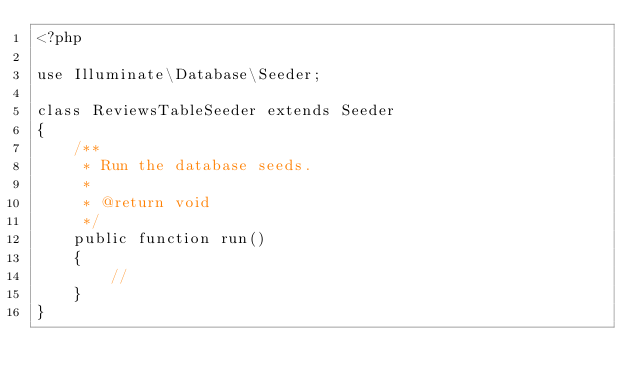Convert code to text. <code><loc_0><loc_0><loc_500><loc_500><_PHP_><?php

use Illuminate\Database\Seeder;

class ReviewsTableSeeder extends Seeder
{
    /**
     * Run the database seeds.
     *
     * @return void
     */
    public function run()
    {
        //
    }
}
</code> 